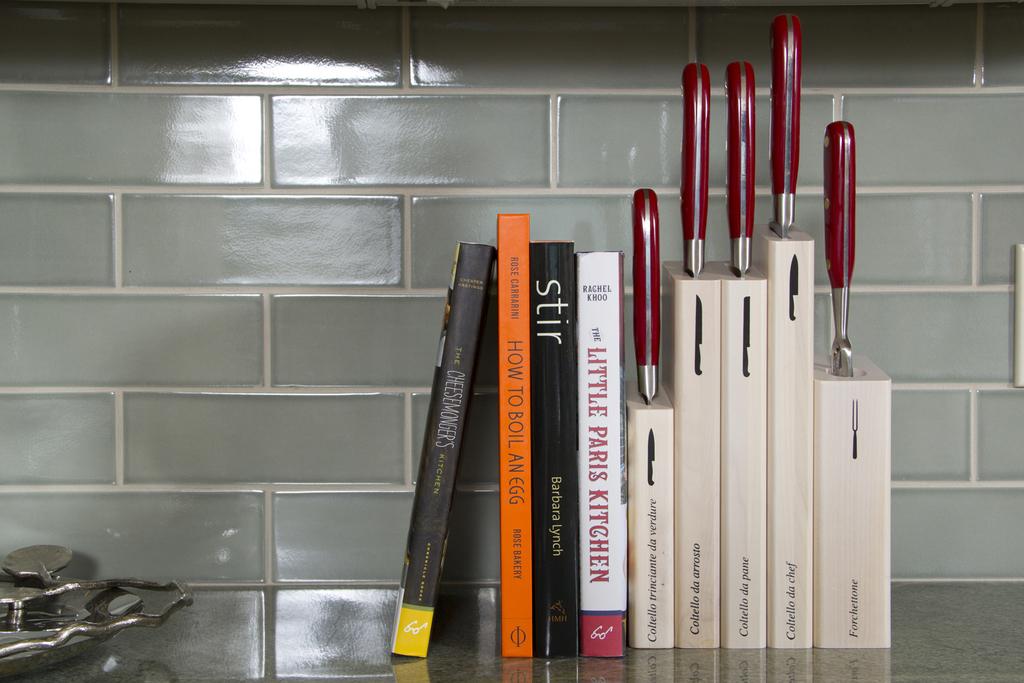What is one of the books on the counter?
Ensure brevity in your answer.  Stir. 